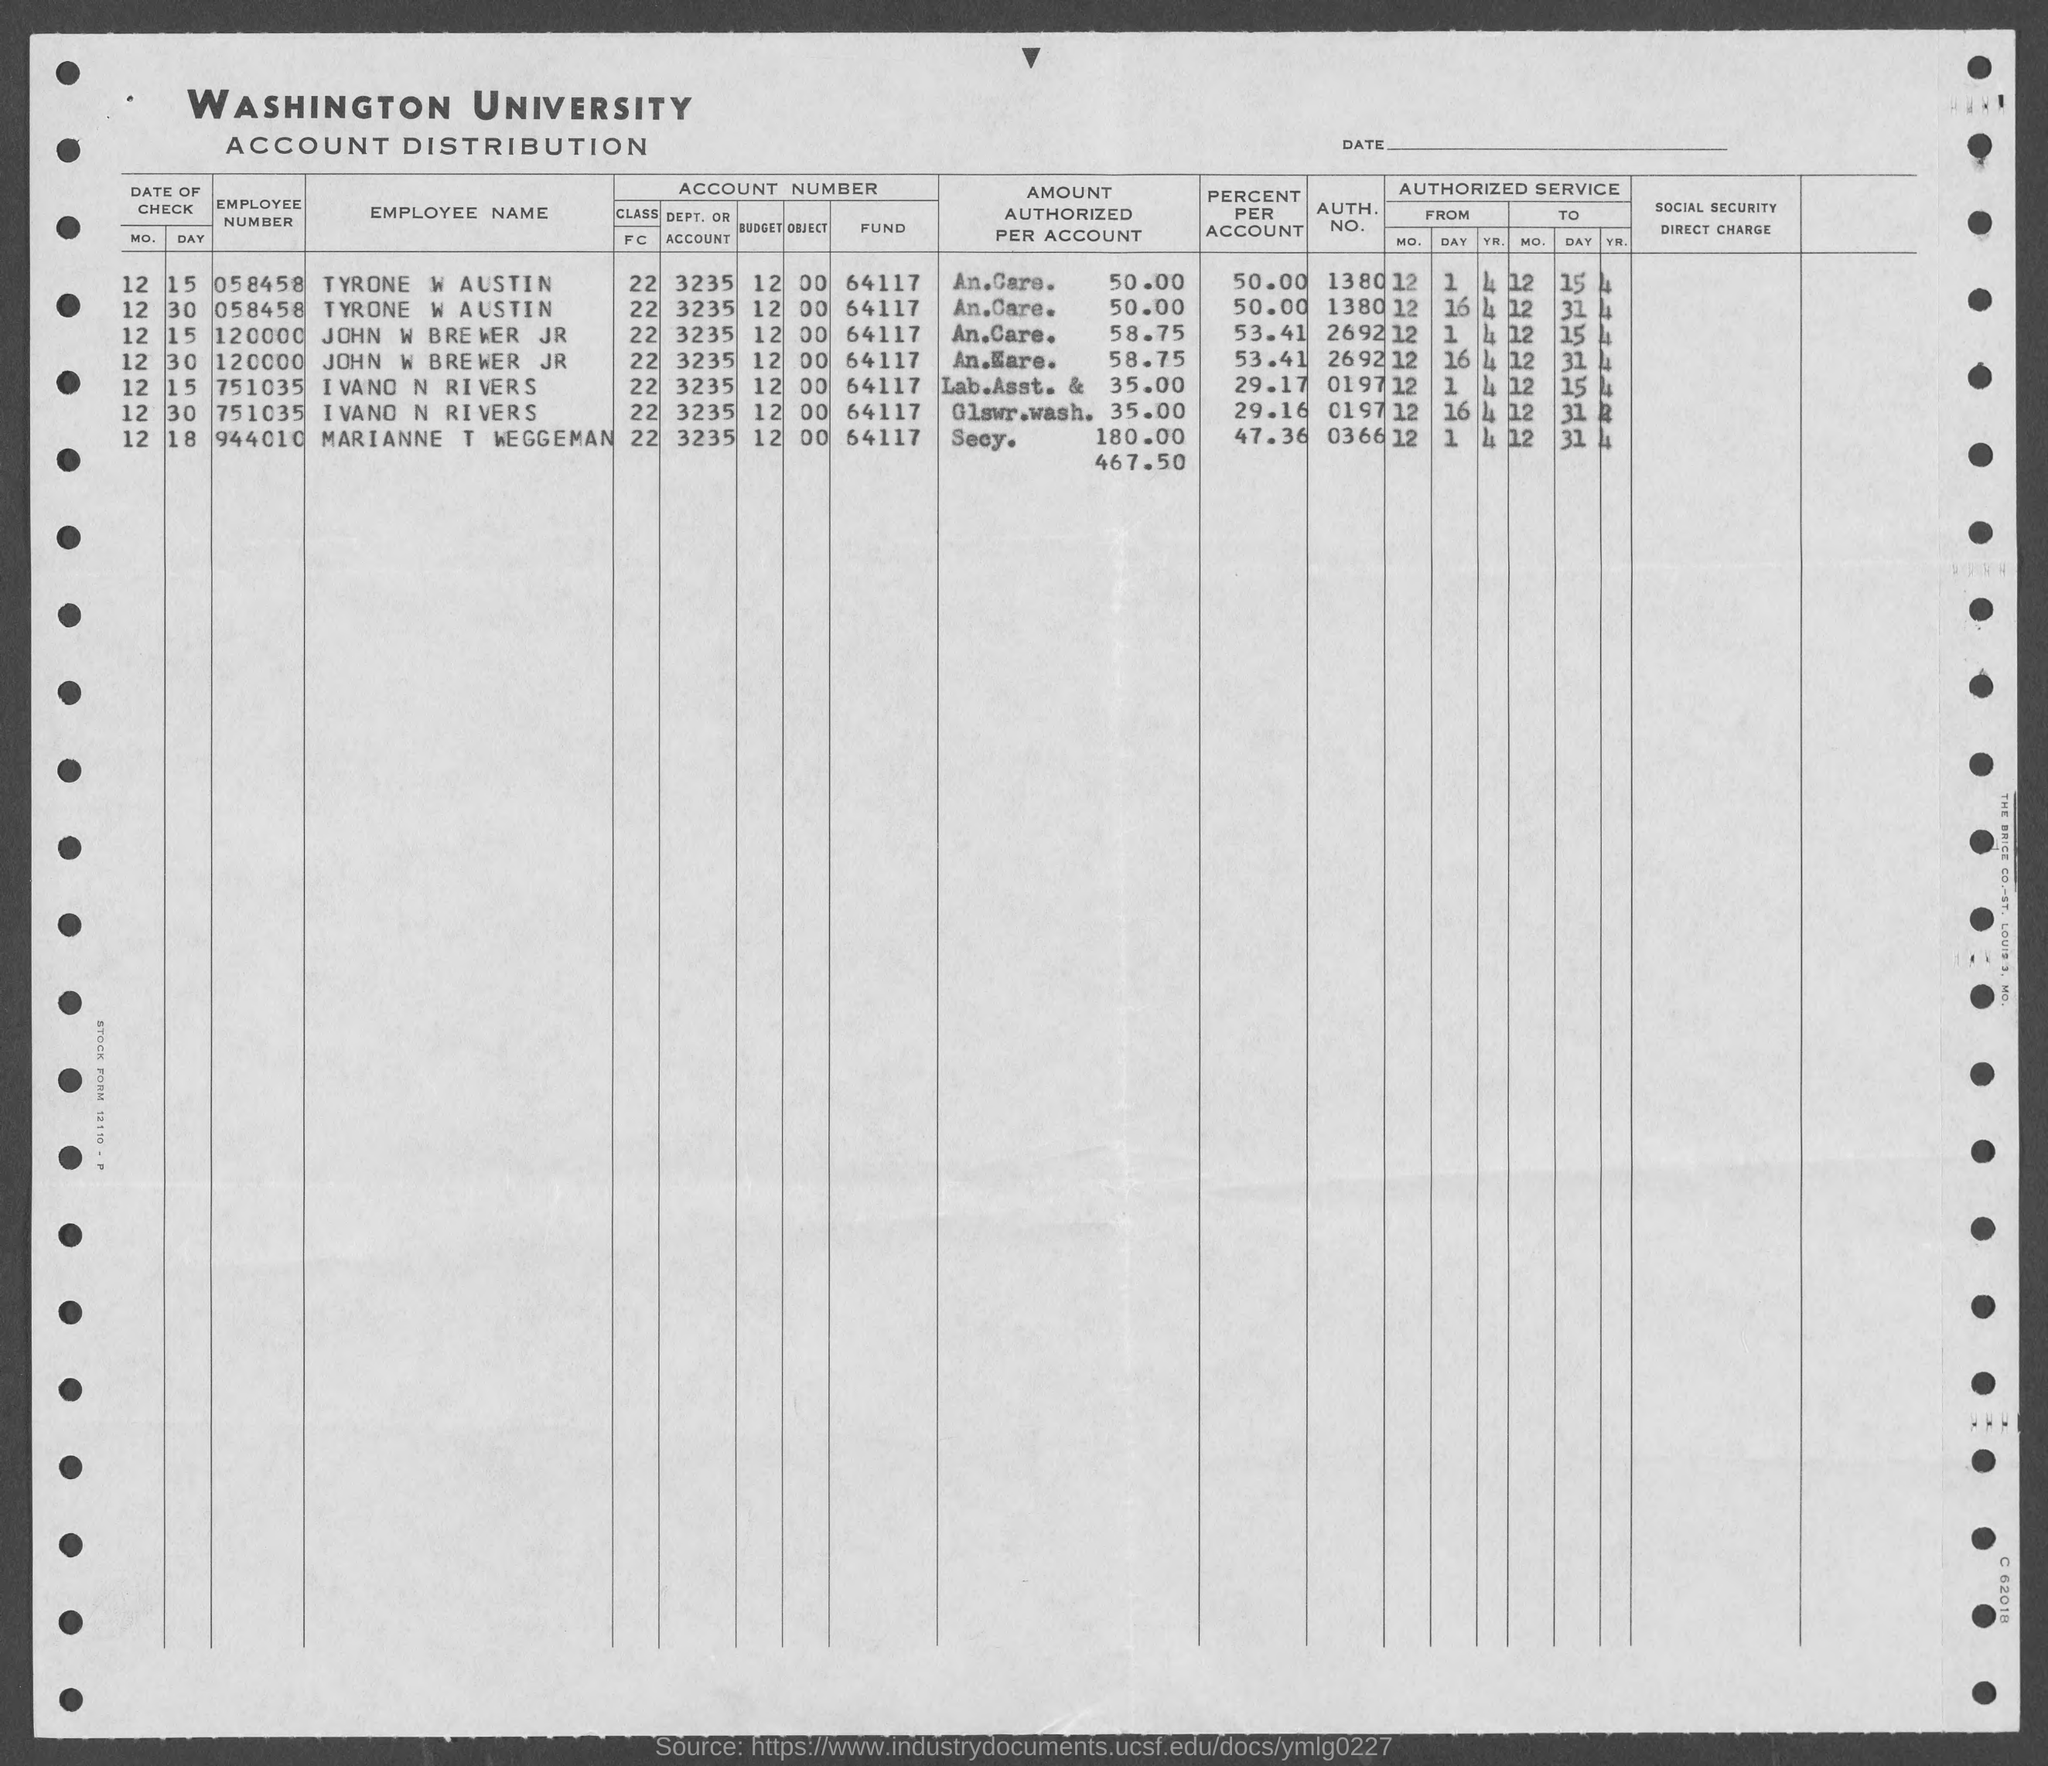Point out several critical features in this image. The employee number of John W. Brewer Jr. is 120000. The authoritative number for John W Brewer Jr is 2692. The employee number of Tyrone W Austin is 058458... The authentication number of Ivano N. Rivers is 0197... What is the account number of Tyrone W Austin? It is 1380... 